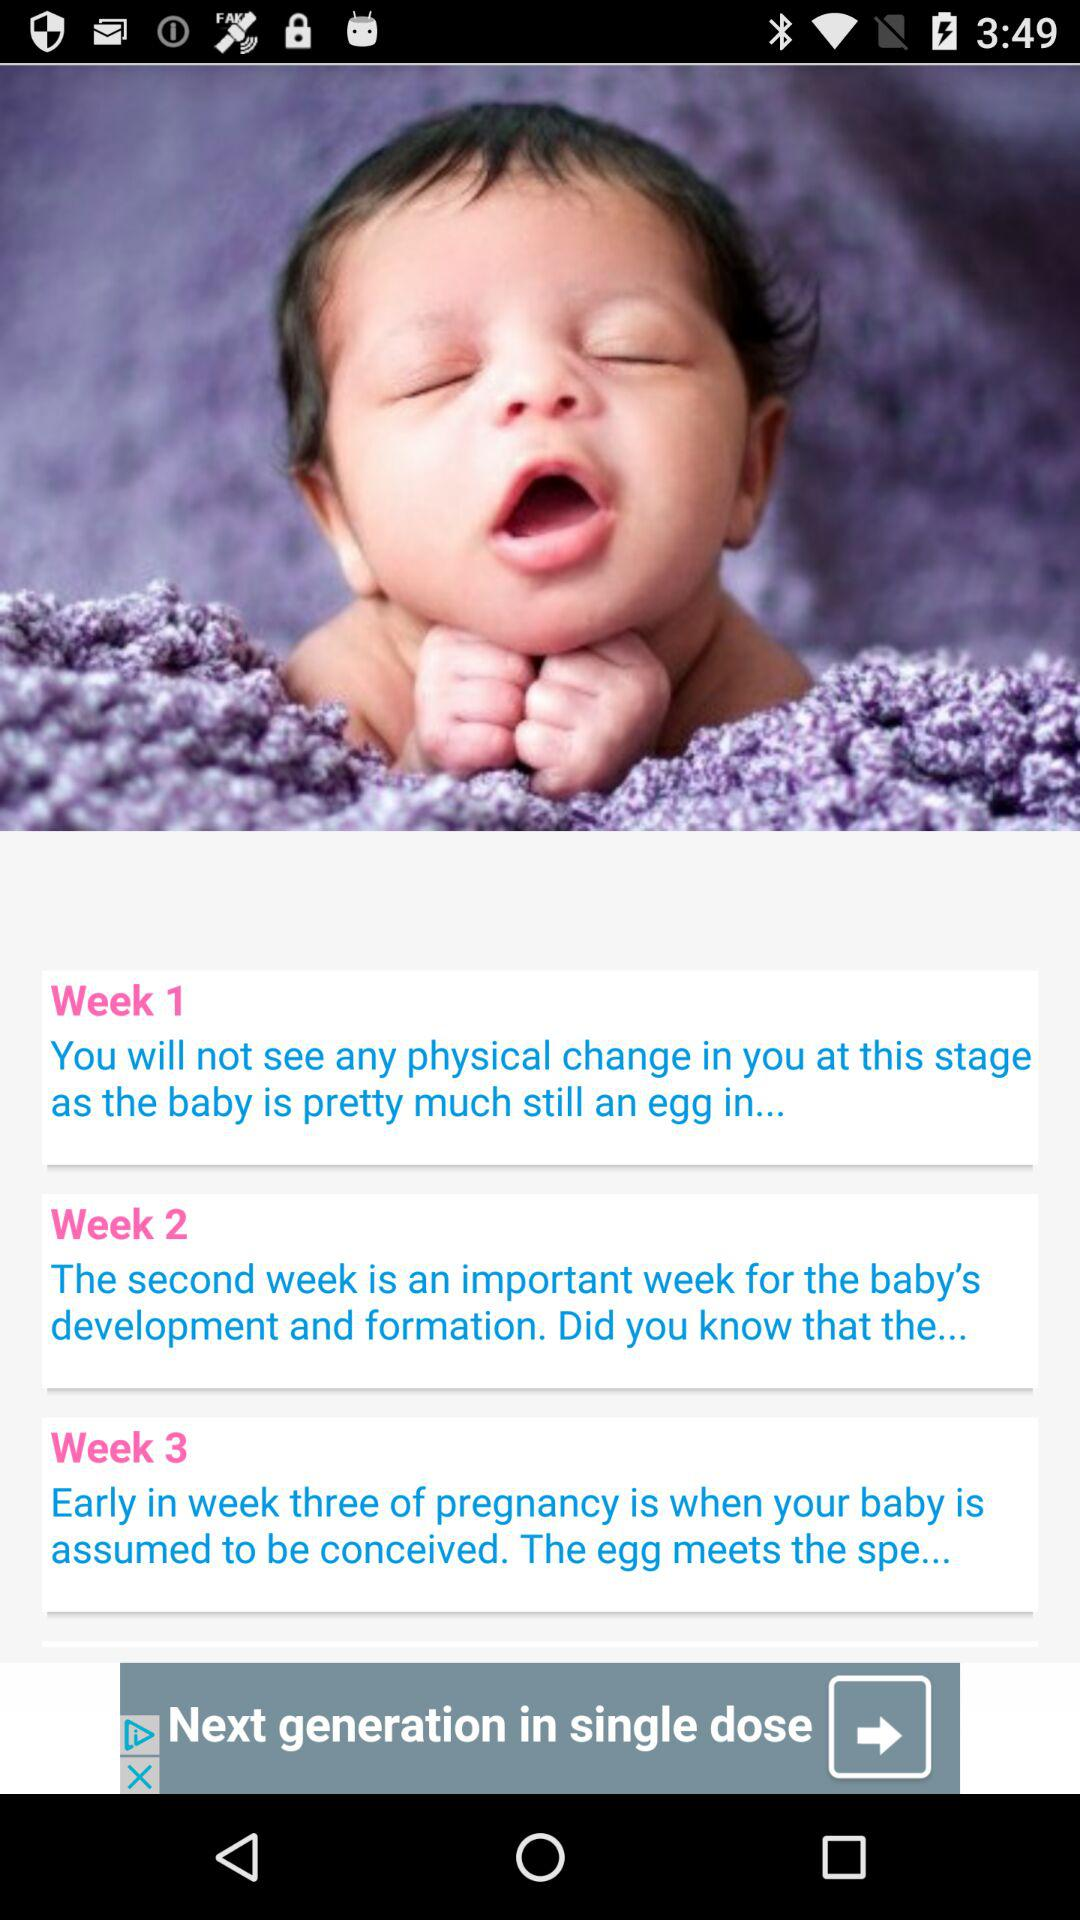In which week baby is assumed to be conceived? The baby is assumed to be conceived in week 3. 